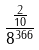Convert formula to latex. <formula><loc_0><loc_0><loc_500><loc_500>\frac { \frac { 2 } { 1 0 } } { 8 ^ { 3 6 6 } }</formula> 